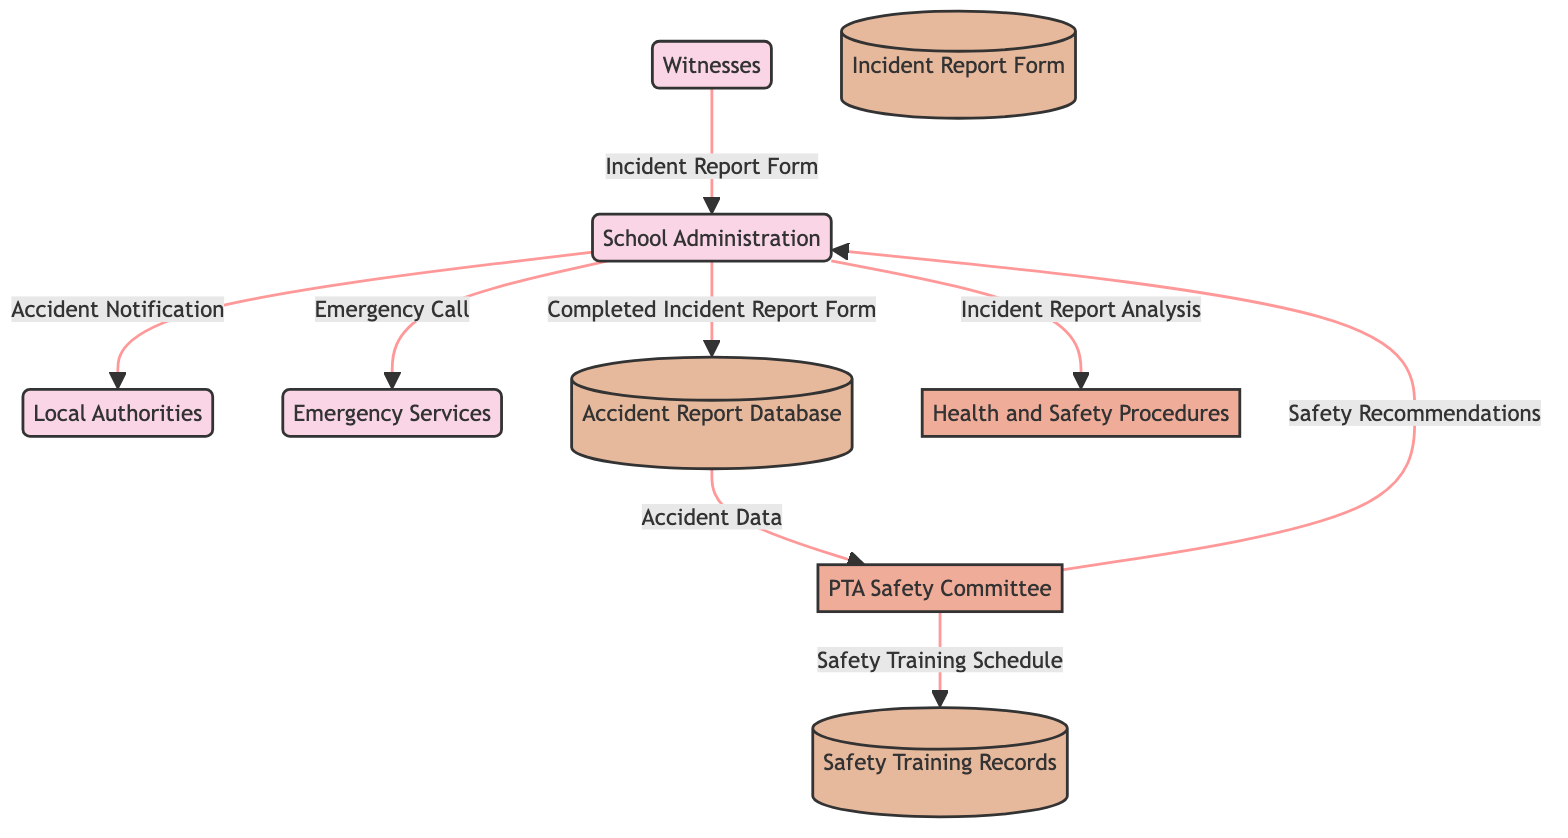What external entity reports accidents to the School Administration? The diagram shows that Witnesses report accidents to the School Administration by providing an Incident Report Form. Thus, Witnesses are the external entities responsible for reporting.
Answer: Witnesses How many data stores are in the diagram? By counting the nodes labeled as data stores in the diagram, we find three data stores: Accident Report Database, Incident Report Form, and Safety Training Records. Therefore, there are three data stores.
Answer: 3 What does the School Administration initiate based on the Incident Report Analysis? The flow shows that the School Administration sends Incident Report Analysis to Health and Safety Procedures, which indicates that it initiates health and safety procedures.
Answer: Health and Safety Procedures Who receives the Accident Data from the Accident Report Database? According to the diagram, the Accident Data flows from the Accident Report Database to the PTA Safety Committee. Therefore, the PTA Safety Committee is the recipient.
Answer: PTA Safety Committee What type of procedure does the PTA Safety Committee provide to the School Administration? The PTA Safety Committee sends Safety Recommendations to the School Administration based on their analysis of the accident data. Consequently, the type of procedure is recommendations.
Answer: Safety Recommendations What action does the School Administration take when contacted by Witnesses? The diagram depicts that when Witnesses report accidents to the School Administration, they provide the Incident Report Form, which leads to subsequent actions, including contacting emergency services. Thus, the action taken is to file the report.
Answer: Incident Report Form How does the School Administration inform Local Authorities about an accident? The diagram indicates that the School Administration sends an Accident Notification to Local Authorities. This notifies them for further investigation. Therefore, the method of informing is through an Accident Notification.
Answer: Accident Notification What relationship exists between the PTA Safety Committee and Safety Training Records? The flow in the diagram signifies that the PTA Safety Committee sends a Safety Training Schedule to Safety Training Records, suggesting a relationship where the committee records their training sessions. Thus, the relationship is one of documentation.
Answer: Documentation 